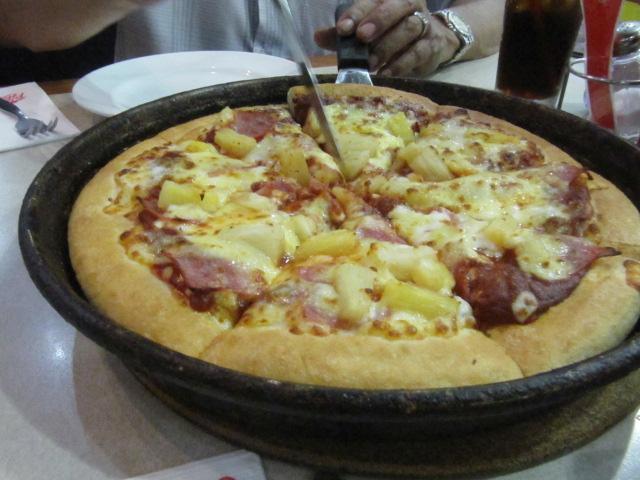How many slices of pizza are there?
Give a very brief answer. 8. 